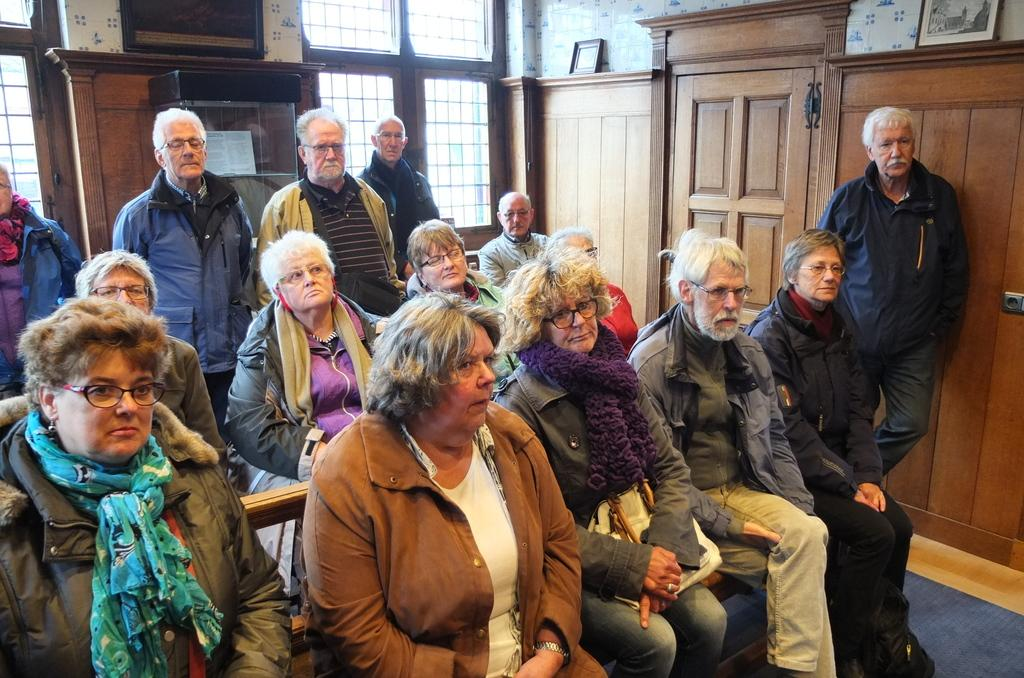What are the people in the image doing? There are people sitting on a bench and people standing in the image. What can be seen on the wall in the image? There are photo frames on the wall in the image. Can you tell me how many pigs are visible in the image? There are no pigs present in the image; it features people sitting and standing, as well as photo frames on the wall. What type of insurance policy is being discussed in the image? There is no mention of insurance or any discussion in the image; it simply shows people sitting and standing, along with photo frames on the wall. 